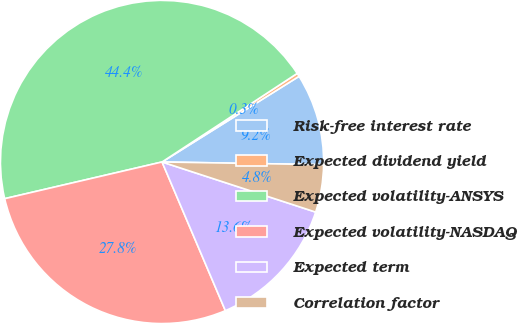Convert chart. <chart><loc_0><loc_0><loc_500><loc_500><pie_chart><fcel>Risk-free interest rate<fcel>Expected dividend yield<fcel>Expected volatility-ANSYS<fcel>Expected volatility-NASDAQ<fcel>Expected term<fcel>Correlation factor<nl><fcel>9.16%<fcel>0.34%<fcel>44.41%<fcel>27.76%<fcel>13.57%<fcel>4.75%<nl></chart> 